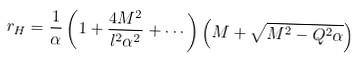Convert formula to latex. <formula><loc_0><loc_0><loc_500><loc_500>r _ { H } = \frac { 1 } { \alpha } \left ( 1 + \frac { 4 M ^ { 2 } } { l ^ { 2 } \alpha ^ { 2 } } + \cdots \right ) \left ( M + \sqrt { M ^ { 2 } - Q ^ { 2 } \alpha } \right )</formula> 